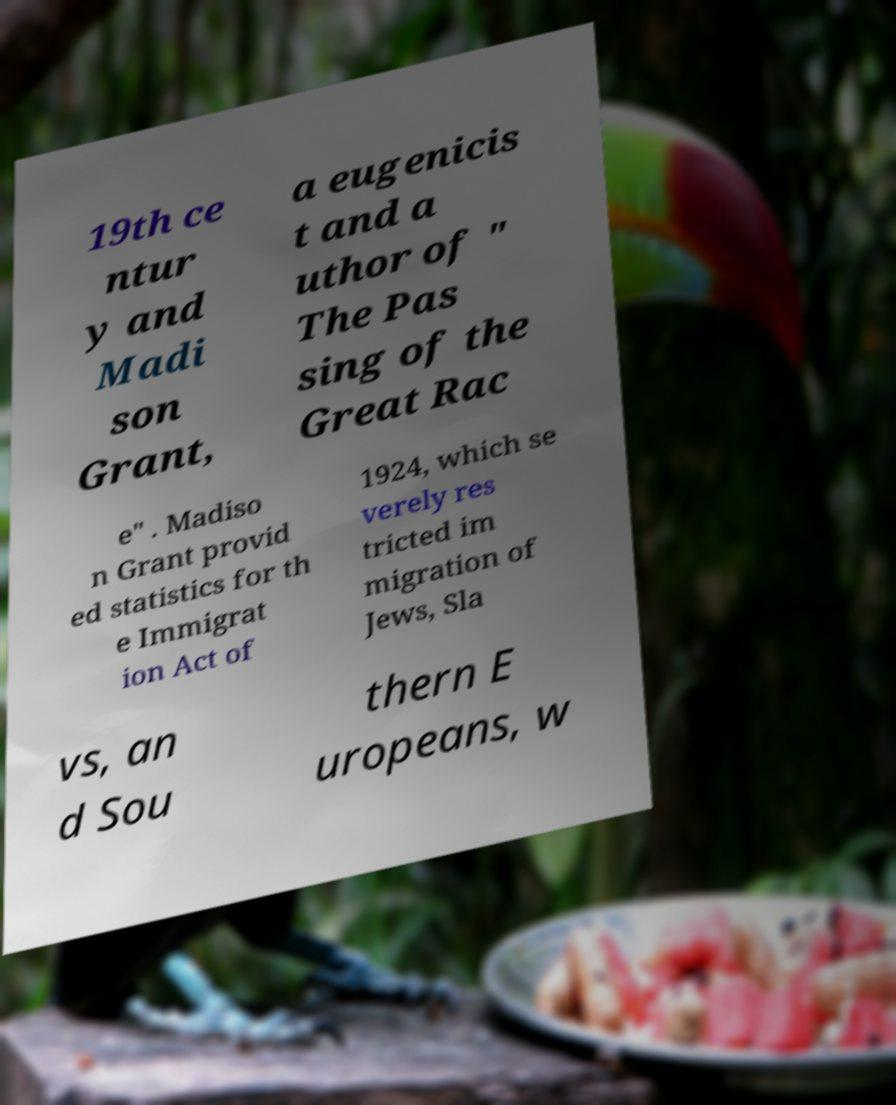There's text embedded in this image that I need extracted. Can you transcribe it verbatim? 19th ce ntur y and Madi son Grant, a eugenicis t and a uthor of " The Pas sing of the Great Rac e" . Madiso n Grant provid ed statistics for th e Immigrat ion Act of 1924, which se verely res tricted im migration of Jews, Sla vs, an d Sou thern E uropeans, w 